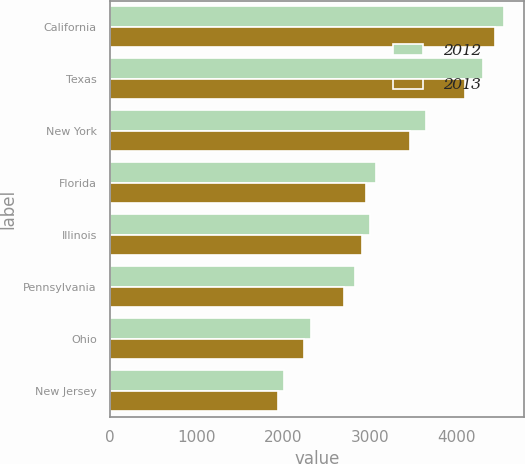<chart> <loc_0><loc_0><loc_500><loc_500><stacked_bar_chart><ecel><fcel>California<fcel>Texas<fcel>New York<fcel>Florida<fcel>Illinois<fcel>Pennsylvania<fcel>Ohio<fcel>New Jersey<nl><fcel>2012<fcel>4548<fcel>4299<fcel>3649<fcel>3064<fcel>2998<fcel>2823<fcel>2324<fcel>2002<nl><fcel>2013<fcel>4442<fcel>4090<fcel>3457<fcel>2949<fcel>2903<fcel>2703<fcel>2233<fcel>1940<nl></chart> 